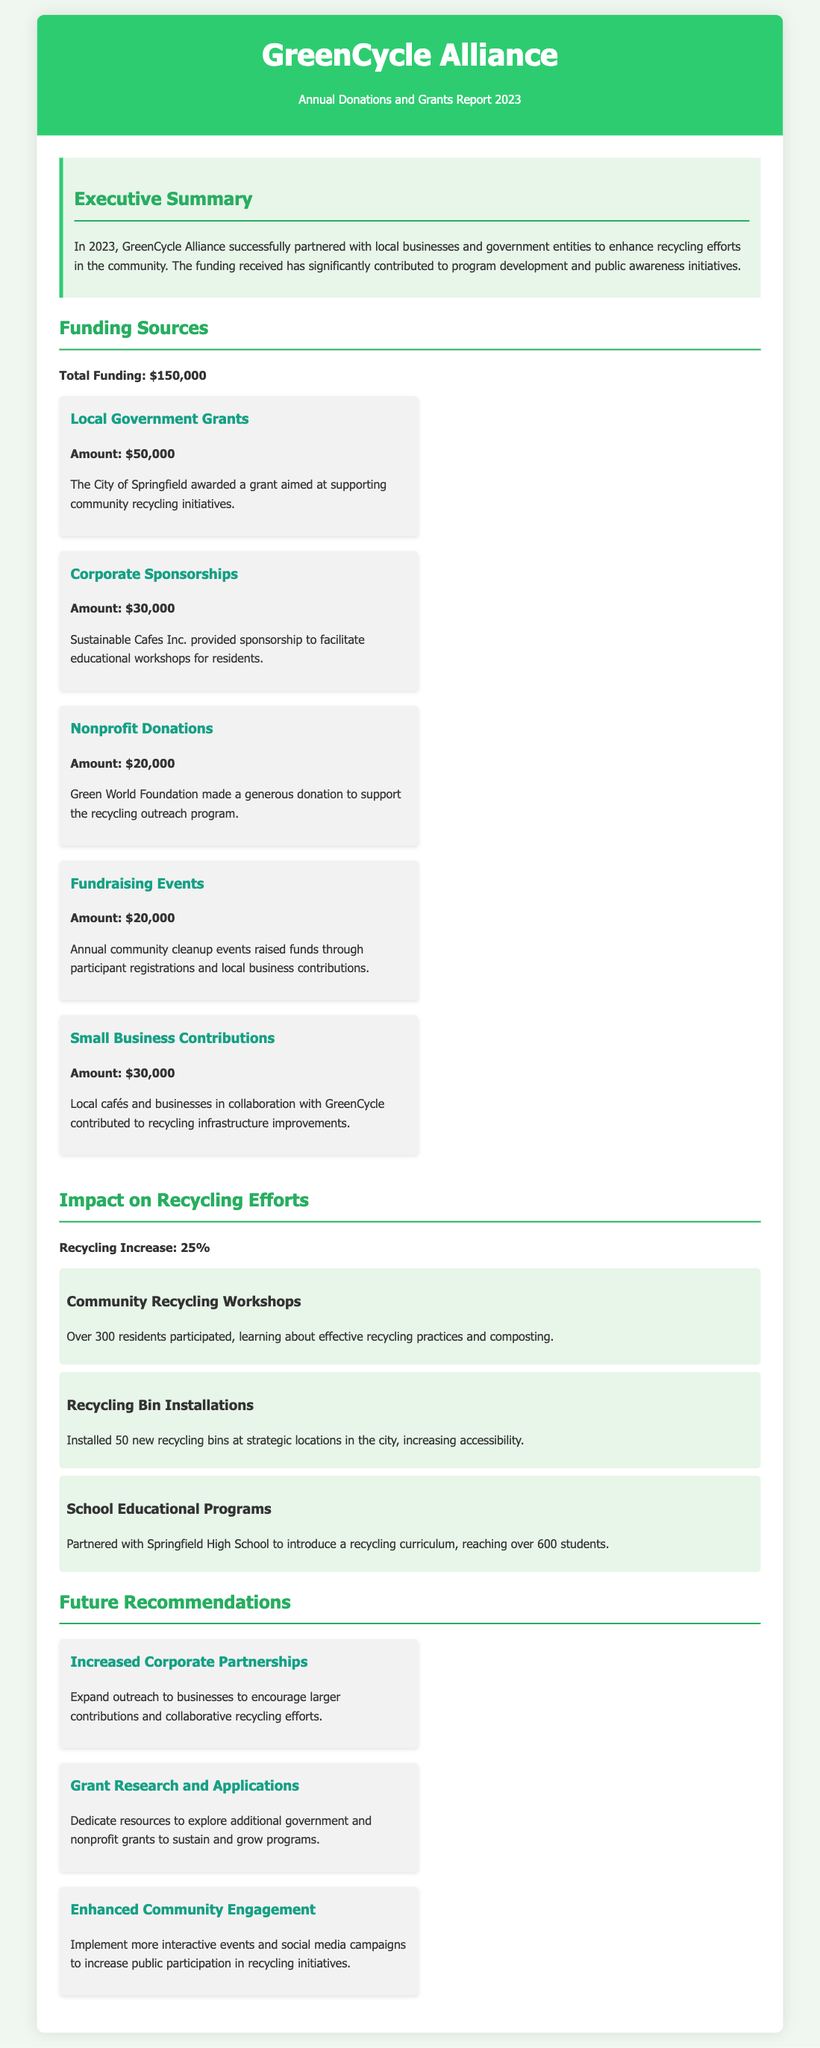what is the total funding received? The total funding is explicitly stated in the report as $150,000.
Answer: $150,000 how much did local government grants contribute? The document specifies that local government grants contributed $50,000.
Answer: $50,000 what is the increase in recycling efforts? The report mentions a 25% increase in recycling efforts due to the funded programs.
Answer: 25% what organization provided corporate sponsorships? The document states that Sustainable Cafes Inc. provided corporate sponsorships.
Answer: Sustainable Cafes Inc how many new recycling bins were installed? The text indicates that 50 new recycling bins were installed in the city.
Answer: 50 which program reached over 600 students? The report highlights that the school educational programs reached over 600 students.
Answer: School Educational Programs what is one recommendation for future actions? One recommendation listed is to increase corporate partnerships for contributions.
Answer: Increased Corporate Partnerships which funding source had the least contribution? According to the document, nonprofit donations had the least contribution of $20,000.
Answer: Nonprofit Donations what is the name of the alliance mentioned in the report? The name of the alliance as indicated in the title is GreenCycle Alliance.
Answer: GreenCycle Alliance 